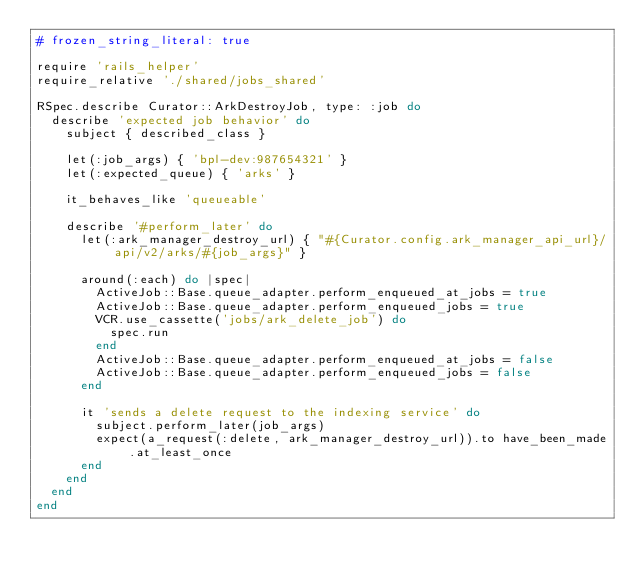<code> <loc_0><loc_0><loc_500><loc_500><_Ruby_># frozen_string_literal: true

require 'rails_helper'
require_relative './shared/jobs_shared'

RSpec.describe Curator::ArkDestroyJob, type: :job do
  describe 'expected job behavior' do
    subject { described_class }

    let(:job_args) { 'bpl-dev:987654321' }
    let(:expected_queue) { 'arks' }

    it_behaves_like 'queueable'

    describe '#perform_later' do
      let(:ark_manager_destroy_url) { "#{Curator.config.ark_manager_api_url}/api/v2/arks/#{job_args}" }

      around(:each) do |spec|
        ActiveJob::Base.queue_adapter.perform_enqueued_at_jobs = true
        ActiveJob::Base.queue_adapter.perform_enqueued_jobs = true
        VCR.use_cassette('jobs/ark_delete_job') do
          spec.run
        end
        ActiveJob::Base.queue_adapter.perform_enqueued_at_jobs = false
        ActiveJob::Base.queue_adapter.perform_enqueued_jobs = false
      end

      it 'sends a delete request to the indexing service' do
        subject.perform_later(job_args)
        expect(a_request(:delete, ark_manager_destroy_url)).to have_been_made.at_least_once
      end
    end
  end
end
</code> 